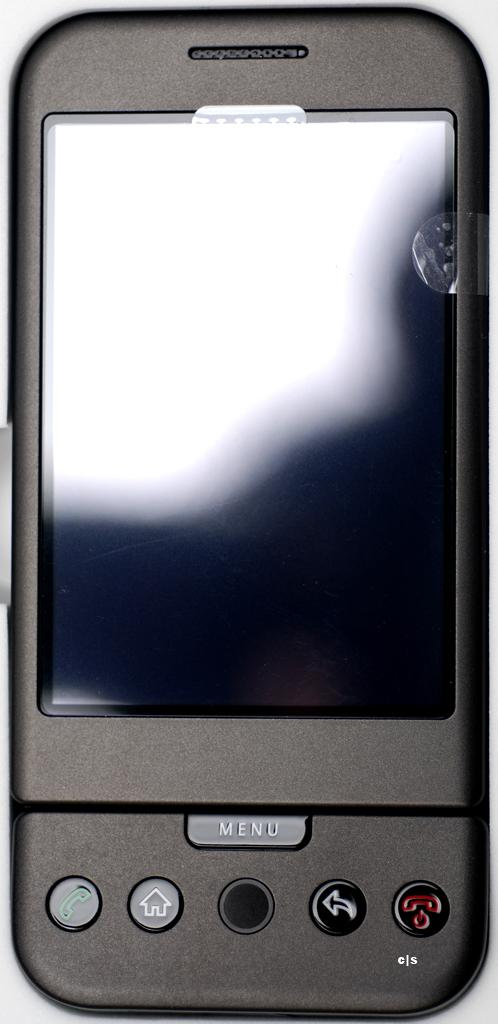<image>
Summarize the visual content of the image. a phone that has the word menu on it 